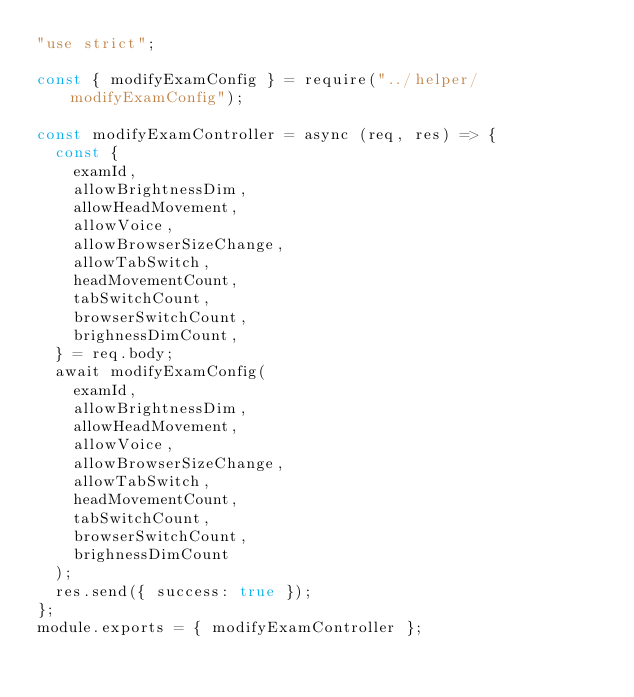Convert code to text. <code><loc_0><loc_0><loc_500><loc_500><_JavaScript_>"use strict";

const { modifyExamConfig } = require("../helper/modifyExamConfig");

const modifyExamController = async (req, res) => {
  const {
    examId,
    allowBrightnessDim,
    allowHeadMovement,
    allowVoice,
    allowBrowserSizeChange,
    allowTabSwitch,
    headMovementCount,
    tabSwitchCount,
    browserSwitchCount,
    brighnessDimCount,
  } = req.body;
  await modifyExamConfig(
    examId,
    allowBrightnessDim,
    allowHeadMovement,
    allowVoice,
    allowBrowserSizeChange,
    allowTabSwitch,
    headMovementCount,
    tabSwitchCount,
    browserSwitchCount,
    brighnessDimCount
  );
  res.send({ success: true });
};
module.exports = { modifyExamController };
</code> 